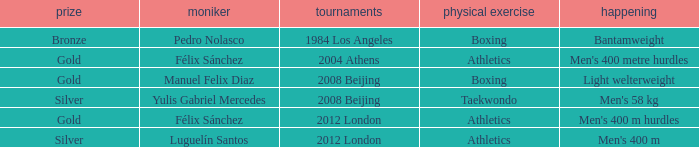What Medal had a Name of manuel felix diaz? Gold. 